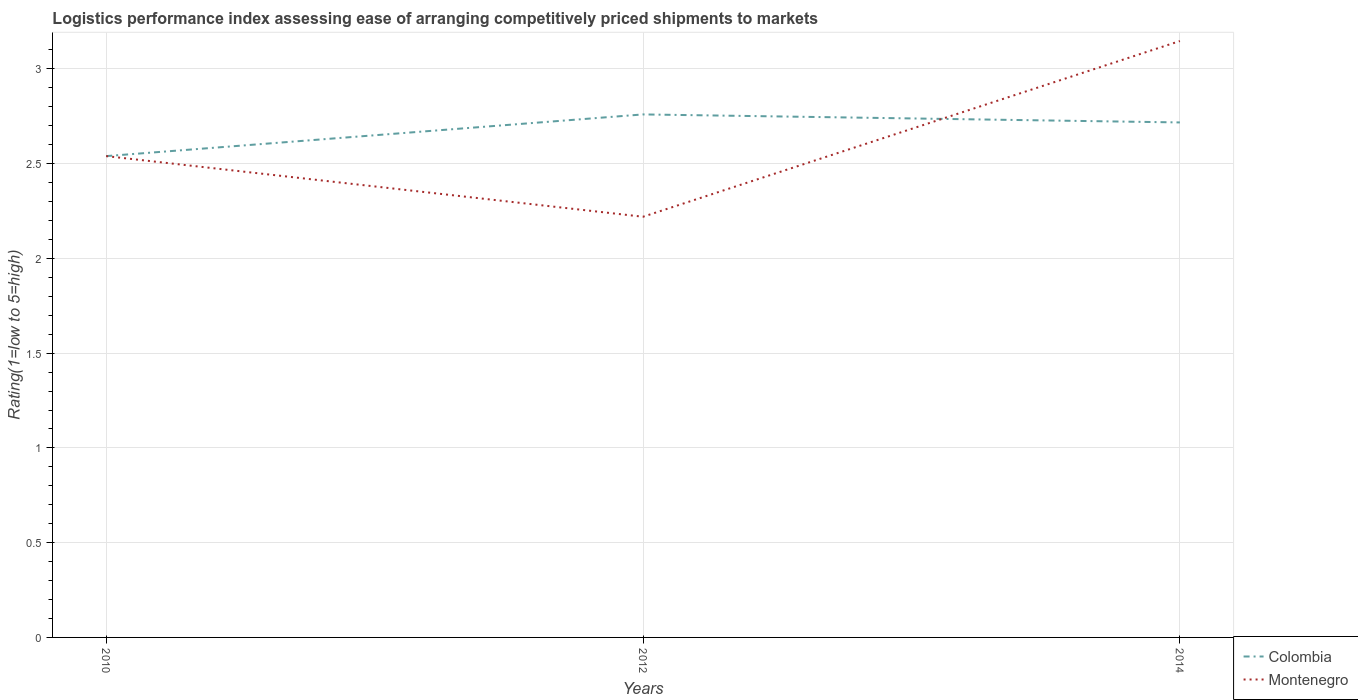How many different coloured lines are there?
Provide a succinct answer. 2. Is the number of lines equal to the number of legend labels?
Ensure brevity in your answer.  Yes. Across all years, what is the maximum Logistic performance index in Colombia?
Keep it short and to the point. 2.54. In which year was the Logistic performance index in Colombia maximum?
Provide a succinct answer. 2010. What is the total Logistic performance index in Montenegro in the graph?
Give a very brief answer. 0.32. What is the difference between the highest and the second highest Logistic performance index in Montenegro?
Provide a short and direct response. 0.93. What is the difference between the highest and the lowest Logistic performance index in Colombia?
Provide a short and direct response. 2. How many lines are there?
Offer a terse response. 2. How many years are there in the graph?
Keep it short and to the point. 3. Does the graph contain any zero values?
Offer a terse response. No. Where does the legend appear in the graph?
Offer a very short reply. Bottom right. How are the legend labels stacked?
Keep it short and to the point. Vertical. What is the title of the graph?
Make the answer very short. Logistics performance index assessing ease of arranging competitively priced shipments to markets. What is the label or title of the Y-axis?
Offer a terse response. Rating(1=low to 5=high). What is the Rating(1=low to 5=high) of Colombia in 2010?
Offer a very short reply. 2.54. What is the Rating(1=low to 5=high) in Montenegro in 2010?
Keep it short and to the point. 2.54. What is the Rating(1=low to 5=high) in Colombia in 2012?
Give a very brief answer. 2.76. What is the Rating(1=low to 5=high) of Montenegro in 2012?
Ensure brevity in your answer.  2.22. What is the Rating(1=low to 5=high) in Colombia in 2014?
Ensure brevity in your answer.  2.72. What is the Rating(1=low to 5=high) in Montenegro in 2014?
Make the answer very short. 3.15. Across all years, what is the maximum Rating(1=low to 5=high) of Colombia?
Provide a succinct answer. 2.76. Across all years, what is the maximum Rating(1=low to 5=high) in Montenegro?
Your response must be concise. 3.15. Across all years, what is the minimum Rating(1=low to 5=high) in Colombia?
Make the answer very short. 2.54. Across all years, what is the minimum Rating(1=low to 5=high) in Montenegro?
Offer a terse response. 2.22. What is the total Rating(1=low to 5=high) in Colombia in the graph?
Provide a succinct answer. 8.02. What is the total Rating(1=low to 5=high) of Montenegro in the graph?
Your response must be concise. 7.91. What is the difference between the Rating(1=low to 5=high) in Colombia in 2010 and that in 2012?
Your answer should be very brief. -0.22. What is the difference between the Rating(1=low to 5=high) of Montenegro in 2010 and that in 2012?
Offer a very short reply. 0.32. What is the difference between the Rating(1=low to 5=high) of Colombia in 2010 and that in 2014?
Keep it short and to the point. -0.18. What is the difference between the Rating(1=low to 5=high) in Montenegro in 2010 and that in 2014?
Keep it short and to the point. -0.61. What is the difference between the Rating(1=low to 5=high) of Colombia in 2012 and that in 2014?
Your response must be concise. 0.04. What is the difference between the Rating(1=low to 5=high) in Montenegro in 2012 and that in 2014?
Your answer should be very brief. -0.93. What is the difference between the Rating(1=low to 5=high) of Colombia in 2010 and the Rating(1=low to 5=high) of Montenegro in 2012?
Offer a terse response. 0.32. What is the difference between the Rating(1=low to 5=high) in Colombia in 2010 and the Rating(1=low to 5=high) in Montenegro in 2014?
Provide a succinct answer. -0.61. What is the difference between the Rating(1=low to 5=high) of Colombia in 2012 and the Rating(1=low to 5=high) of Montenegro in 2014?
Your answer should be very brief. -0.39. What is the average Rating(1=low to 5=high) in Colombia per year?
Offer a very short reply. 2.67. What is the average Rating(1=low to 5=high) of Montenegro per year?
Keep it short and to the point. 2.64. In the year 2010, what is the difference between the Rating(1=low to 5=high) of Colombia and Rating(1=low to 5=high) of Montenegro?
Make the answer very short. 0. In the year 2012, what is the difference between the Rating(1=low to 5=high) of Colombia and Rating(1=low to 5=high) of Montenegro?
Make the answer very short. 0.54. In the year 2014, what is the difference between the Rating(1=low to 5=high) of Colombia and Rating(1=low to 5=high) of Montenegro?
Make the answer very short. -0.43. What is the ratio of the Rating(1=low to 5=high) in Colombia in 2010 to that in 2012?
Make the answer very short. 0.92. What is the ratio of the Rating(1=low to 5=high) in Montenegro in 2010 to that in 2012?
Keep it short and to the point. 1.14. What is the ratio of the Rating(1=low to 5=high) in Colombia in 2010 to that in 2014?
Provide a short and direct response. 0.93. What is the ratio of the Rating(1=low to 5=high) in Montenegro in 2010 to that in 2014?
Your answer should be very brief. 0.81. What is the ratio of the Rating(1=low to 5=high) of Colombia in 2012 to that in 2014?
Keep it short and to the point. 1.02. What is the ratio of the Rating(1=low to 5=high) in Montenegro in 2012 to that in 2014?
Keep it short and to the point. 0.71. What is the difference between the highest and the second highest Rating(1=low to 5=high) in Colombia?
Provide a short and direct response. 0.04. What is the difference between the highest and the second highest Rating(1=low to 5=high) of Montenegro?
Keep it short and to the point. 0.61. What is the difference between the highest and the lowest Rating(1=low to 5=high) of Colombia?
Provide a short and direct response. 0.22. What is the difference between the highest and the lowest Rating(1=low to 5=high) in Montenegro?
Provide a succinct answer. 0.93. 